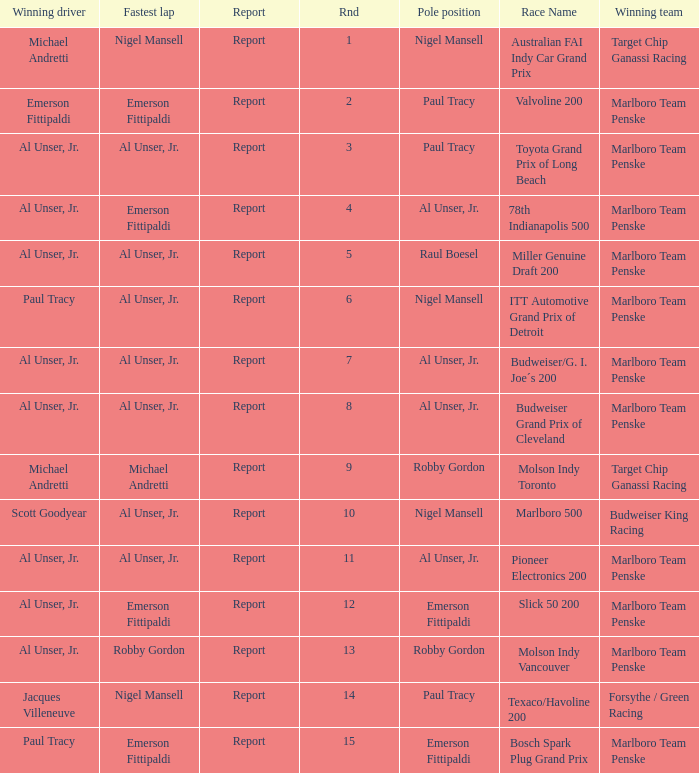Who did the fastest lap in the race won by Paul Tracy, with Emerson Fittipaldi at the pole position? Emerson Fittipaldi. 